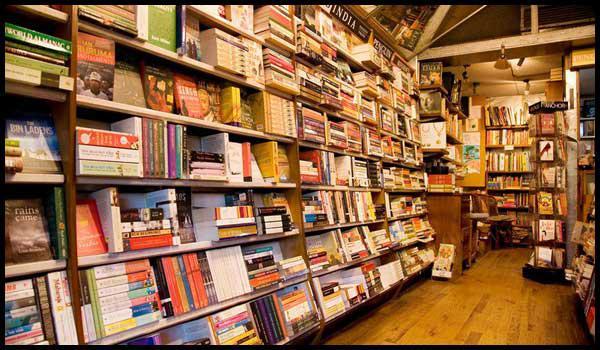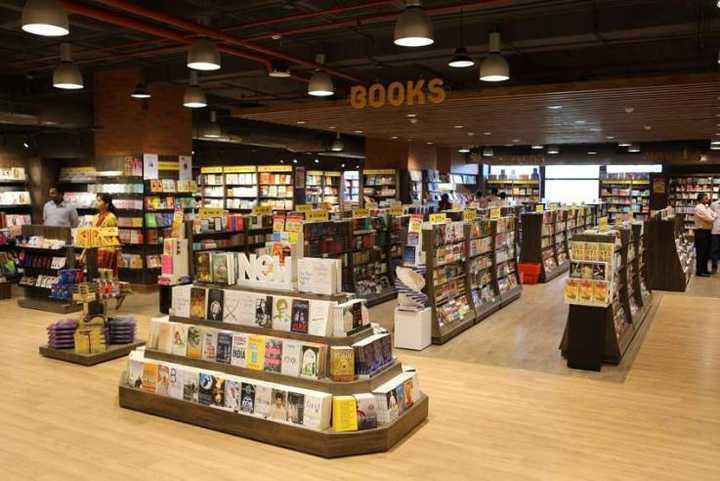The first image is the image on the left, the second image is the image on the right. Analyze the images presented: Is the assertion "The name of the store is visible in exactly one of the images." valid? Answer yes or no. No. The first image is the image on the left, the second image is the image on the right. Analyze the images presented: Is the assertion "One bookshop interior features a dimensional tiered display of books in front of aisles of book shelves and an exposed beam ceiling with dome-shaped lights." valid? Answer yes or no. Yes. 